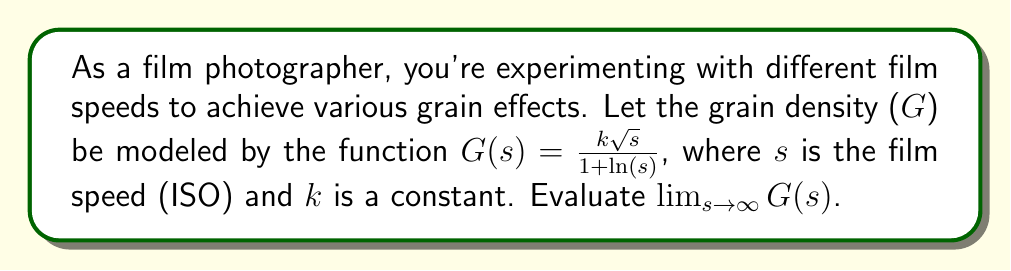Help me with this question. To evaluate this limit, we'll follow these steps:

1) First, let's examine the behavior of the numerator and denominator separately as s approaches infinity:

   Numerator: $k\sqrt{s}$ grows more slowly than s
   Denominator: $1+\ln(s)$ grows even more slowly than $\sqrt{s}$

2) We can apply L'Hôpital's rule, which states that for functions f(x) and g(x) that both approach infinity as x approaches infinity, $\lim_{x \to \infty} \frac{f(x)}{g(x)} = \lim_{x \to \infty} \frac{f'(x)}{g'(x)}$ if this new limit exists.

3) Let's differentiate the numerator and denominator:

   $\frac{d}{ds}(k\sqrt{s}) = \frac{k}{2\sqrt{s}}$
   $\frac{d}{ds}(1+\ln(s)) = \frac{1}{s}$

4) Now our limit becomes:

   $$\lim_{s \to \infty} \frac{\frac{k}{2\sqrt{s}}}{\frac{1}{s}} = \lim_{s \to \infty} \frac{k\sqrt{s}}{2}$$

5) As s approaches infinity, this limit clearly approaches infinity as well.

Therefore, the grain density increases without bound as film speed approaches infinity.
Answer: $\infty$ 